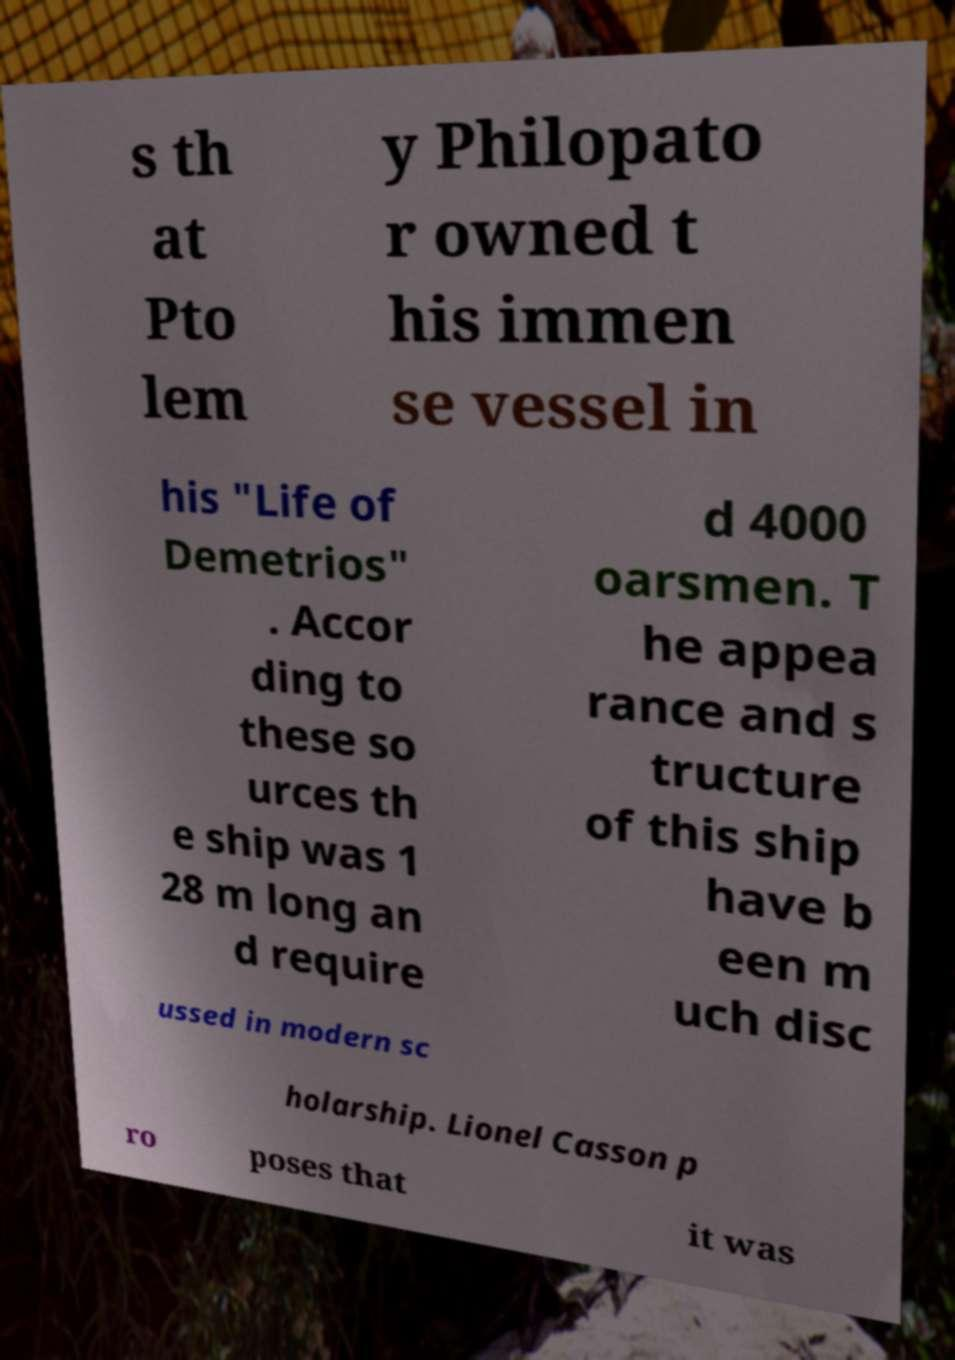What messages or text are displayed in this image? I need them in a readable, typed format. s th at Pto lem y Philopato r owned t his immen se vessel in his "Life of Demetrios" . Accor ding to these so urces th e ship was 1 28 m long an d require d 4000 oarsmen. T he appea rance and s tructure of this ship have b een m uch disc ussed in modern sc holarship. Lionel Casson p ro poses that it was 